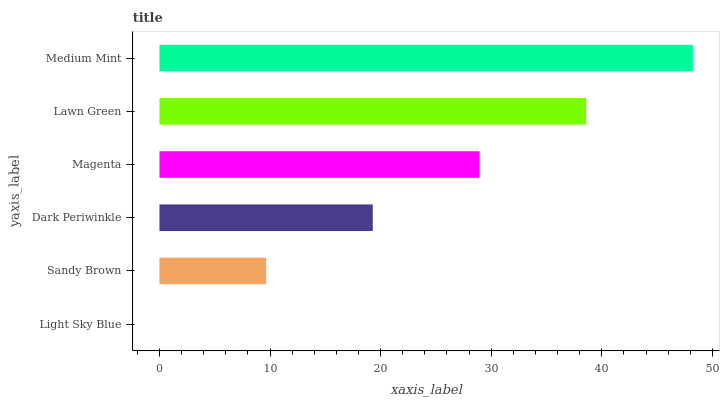Is Light Sky Blue the minimum?
Answer yes or no. Yes. Is Medium Mint the maximum?
Answer yes or no. Yes. Is Sandy Brown the minimum?
Answer yes or no. No. Is Sandy Brown the maximum?
Answer yes or no. No. Is Sandy Brown greater than Light Sky Blue?
Answer yes or no. Yes. Is Light Sky Blue less than Sandy Brown?
Answer yes or no. Yes. Is Light Sky Blue greater than Sandy Brown?
Answer yes or no. No. Is Sandy Brown less than Light Sky Blue?
Answer yes or no. No. Is Magenta the high median?
Answer yes or no. Yes. Is Dark Periwinkle the low median?
Answer yes or no. Yes. Is Lawn Green the high median?
Answer yes or no. No. Is Light Sky Blue the low median?
Answer yes or no. No. 